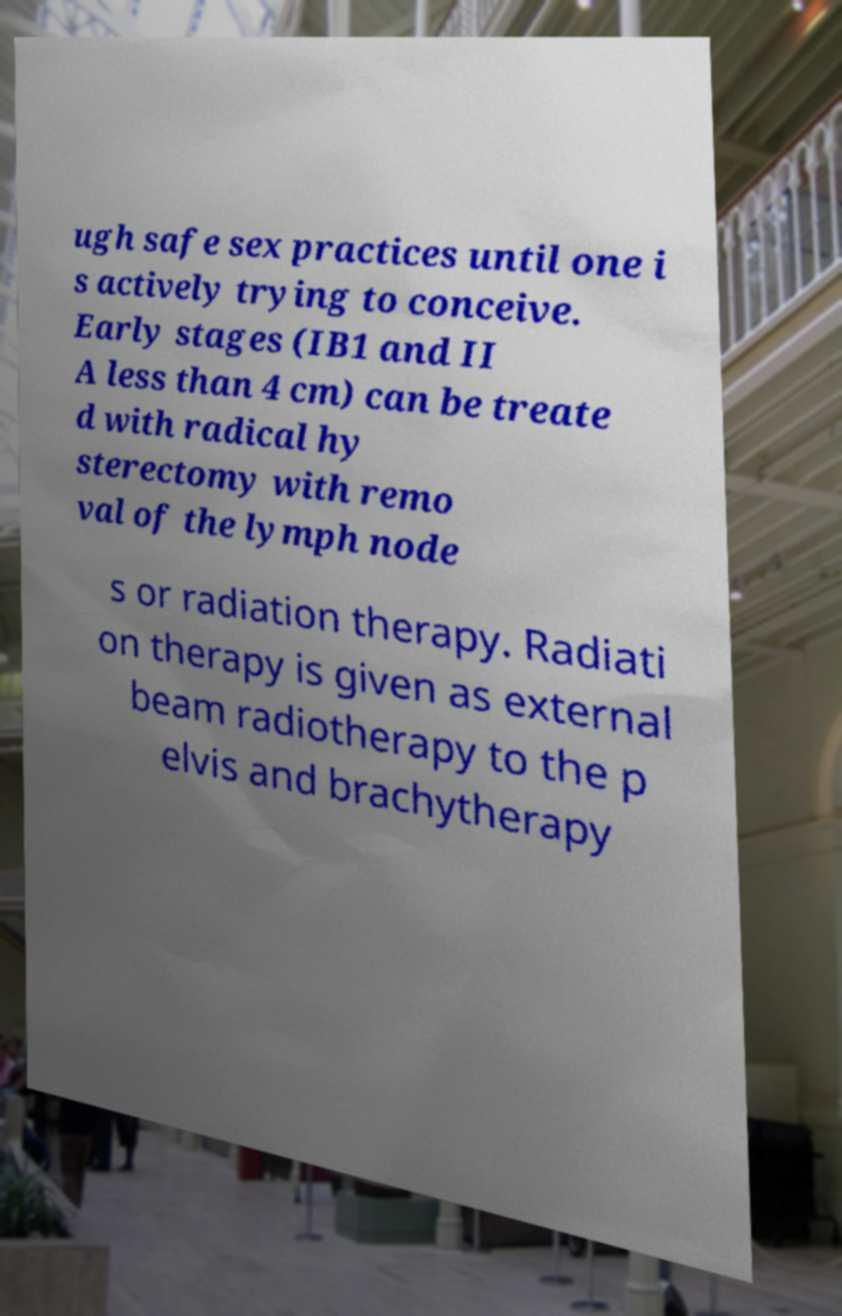Please read and relay the text visible in this image. What does it say? ugh safe sex practices until one i s actively trying to conceive. Early stages (IB1 and II A less than 4 cm) can be treate d with radical hy sterectomy with remo val of the lymph node s or radiation therapy. Radiati on therapy is given as external beam radiotherapy to the p elvis and brachytherapy 